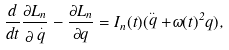Convert formula to latex. <formula><loc_0><loc_0><loc_500><loc_500>\frac { d } { d t } \frac { \partial L _ { n } } { \partial \stackrel { . } { q } } - \frac { \partial L _ { n } } { \partial q } = I _ { n } ( t ) ( \stackrel { . . } { q } + \omega ( t ) ^ { 2 } q ) ,</formula> 